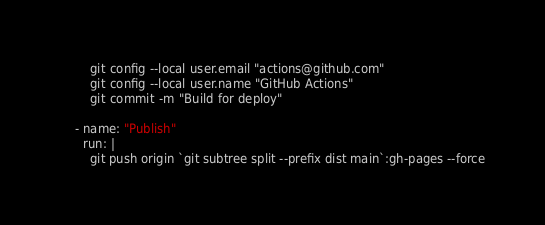Convert code to text. <code><loc_0><loc_0><loc_500><loc_500><_YAML_>        git config --local user.email "actions@github.com"
        git config --local user.name "GitHub Actions"
        git commit -m "Build for deploy"
    
    - name: "Publish"
      run: |
        git push origin `git subtree split --prefix dist main`:gh-pages --force
</code> 